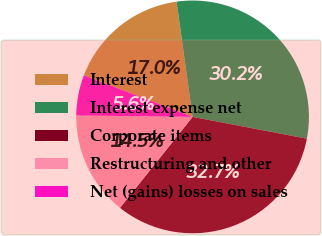Convert chart. <chart><loc_0><loc_0><loc_500><loc_500><pie_chart><fcel>Interest<fcel>Interest expense net<fcel>Corporate items<fcel>Restructuring and other<fcel>Net (gains) losses on sales<nl><fcel>16.98%<fcel>30.2%<fcel>32.72%<fcel>14.47%<fcel>5.63%<nl></chart> 